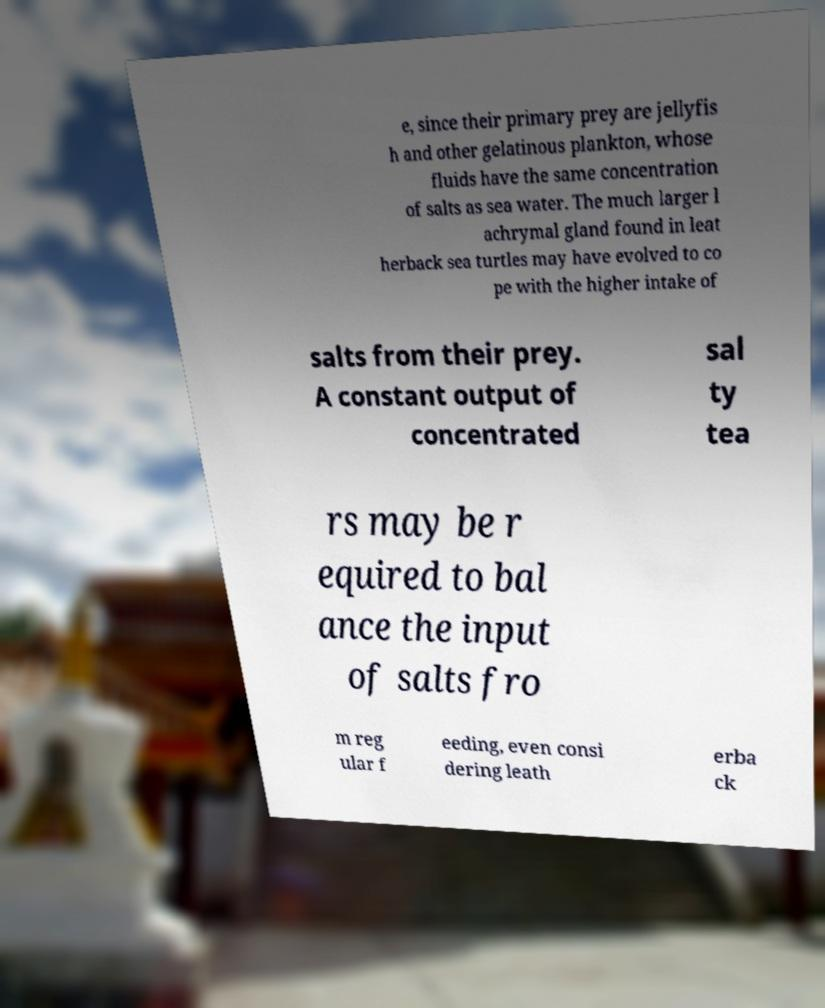I need the written content from this picture converted into text. Can you do that? e, since their primary prey are jellyfis h and other gelatinous plankton, whose fluids have the same concentration of salts as sea water. The much larger l achrymal gland found in leat herback sea turtles may have evolved to co pe with the higher intake of salts from their prey. A constant output of concentrated sal ty tea rs may be r equired to bal ance the input of salts fro m reg ular f eeding, even consi dering leath erba ck 